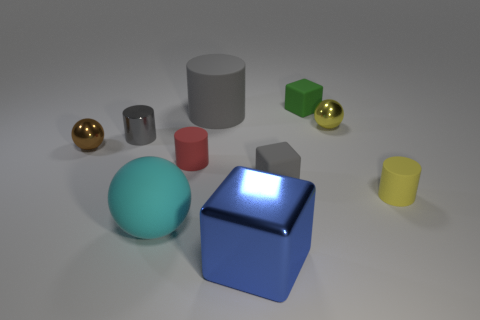There is a matte cylinder right of the big blue thing; is its size the same as the matte block that is behind the gray matte cube?
Your answer should be compact. Yes. The tiny matte thing behind the metal sphere left of the tiny red cylinder is what shape?
Keep it short and to the point. Cube. What number of big objects are behind the small yellow rubber cylinder?
Provide a short and direct response. 1. What color is the small cylinder that is the same material as the blue block?
Ensure brevity in your answer.  Gray. Do the blue thing and the gray thing that is right of the large gray rubber cylinder have the same size?
Provide a short and direct response. No. There is a sphere in front of the yellow object that is on the right side of the small metal ball that is right of the gray shiny cylinder; what size is it?
Your response must be concise. Large. How many matte objects are green blocks or cubes?
Make the answer very short. 2. There is a tiny cylinder that is behind the brown shiny object; what color is it?
Offer a terse response. Gray. What is the shape of the gray metal thing that is the same size as the red cylinder?
Ensure brevity in your answer.  Cylinder. There is a rubber ball; is it the same color as the tiny cube in front of the shiny cylinder?
Keep it short and to the point. No. 